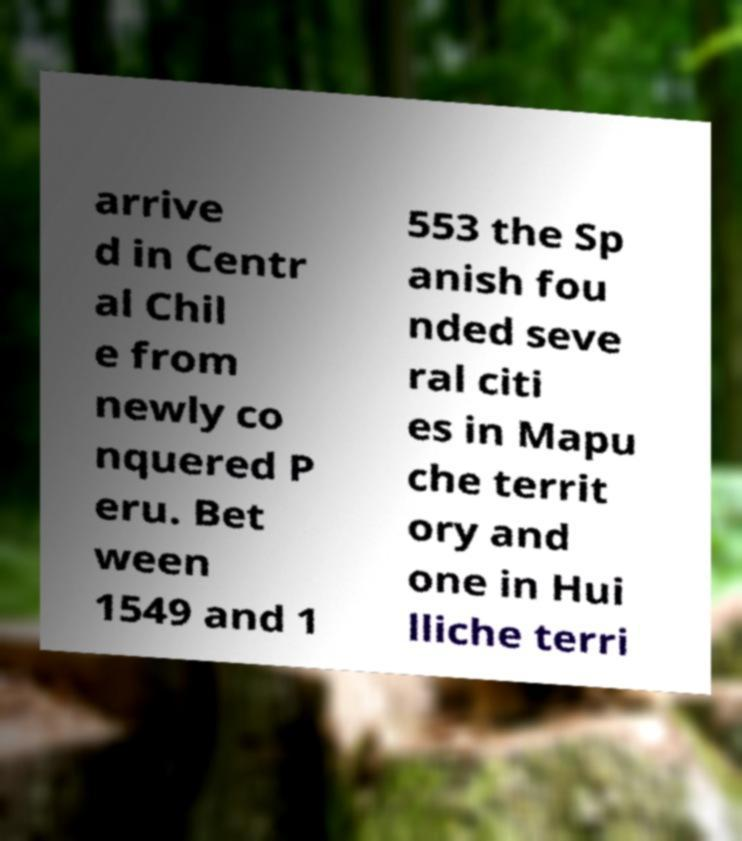What messages or text are displayed in this image? I need them in a readable, typed format. arrive d in Centr al Chil e from newly co nquered P eru. Bet ween 1549 and 1 553 the Sp anish fou nded seve ral citi es in Mapu che territ ory and one in Hui lliche terri 